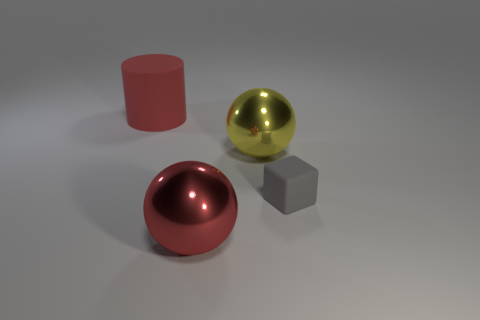Subtract all blue cylinders. Subtract all gray balls. How many cylinders are left? 1 Add 1 small gray matte cubes. How many objects exist? 5 Subtract all cubes. How many objects are left? 3 Subtract all big yellow shiny spheres. Subtract all balls. How many objects are left? 1 Add 4 cylinders. How many cylinders are left? 5 Add 4 large green cubes. How many large green cubes exist? 4 Subtract 0 blue cubes. How many objects are left? 4 